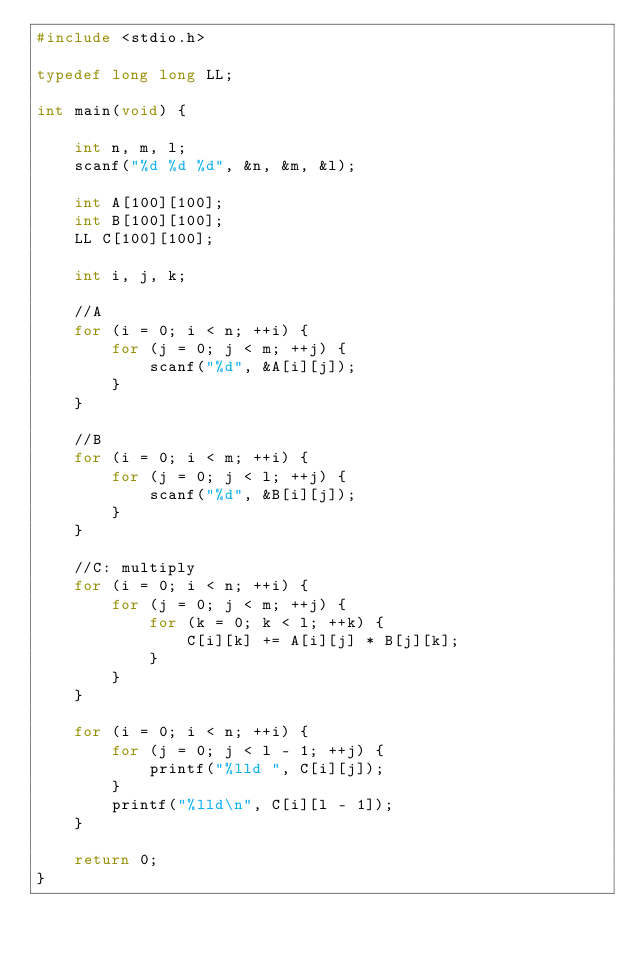Convert code to text. <code><loc_0><loc_0><loc_500><loc_500><_C_>#include <stdio.h>

typedef long long LL;

int main(void) {

    int n, m, l;
    scanf("%d %d %d", &n, &m, &l);

    int A[100][100];
    int B[100][100];
    LL C[100][100];

    int i, j, k;

    //A
    for (i = 0; i < n; ++i) {
        for (j = 0; j < m; ++j) {
            scanf("%d", &A[i][j]);
        }
    }

    //B
    for (i = 0; i < m; ++i) {
        for (j = 0; j < l; ++j) {
            scanf("%d", &B[i][j]);
        }
    }

    //C: multiply
    for (i = 0; i < n; ++i) {
        for (j = 0; j < m; ++j) {
            for (k = 0; k < l; ++k) {
                C[i][k] += A[i][j] * B[j][k];
            }
        }
    }

    for (i = 0; i < n; ++i) {
        for (j = 0; j < l - 1; ++j) {
            printf("%lld ", C[i][j]);
        }
        printf("%lld\n", C[i][l - 1]);
    }

    return 0;
}</code> 